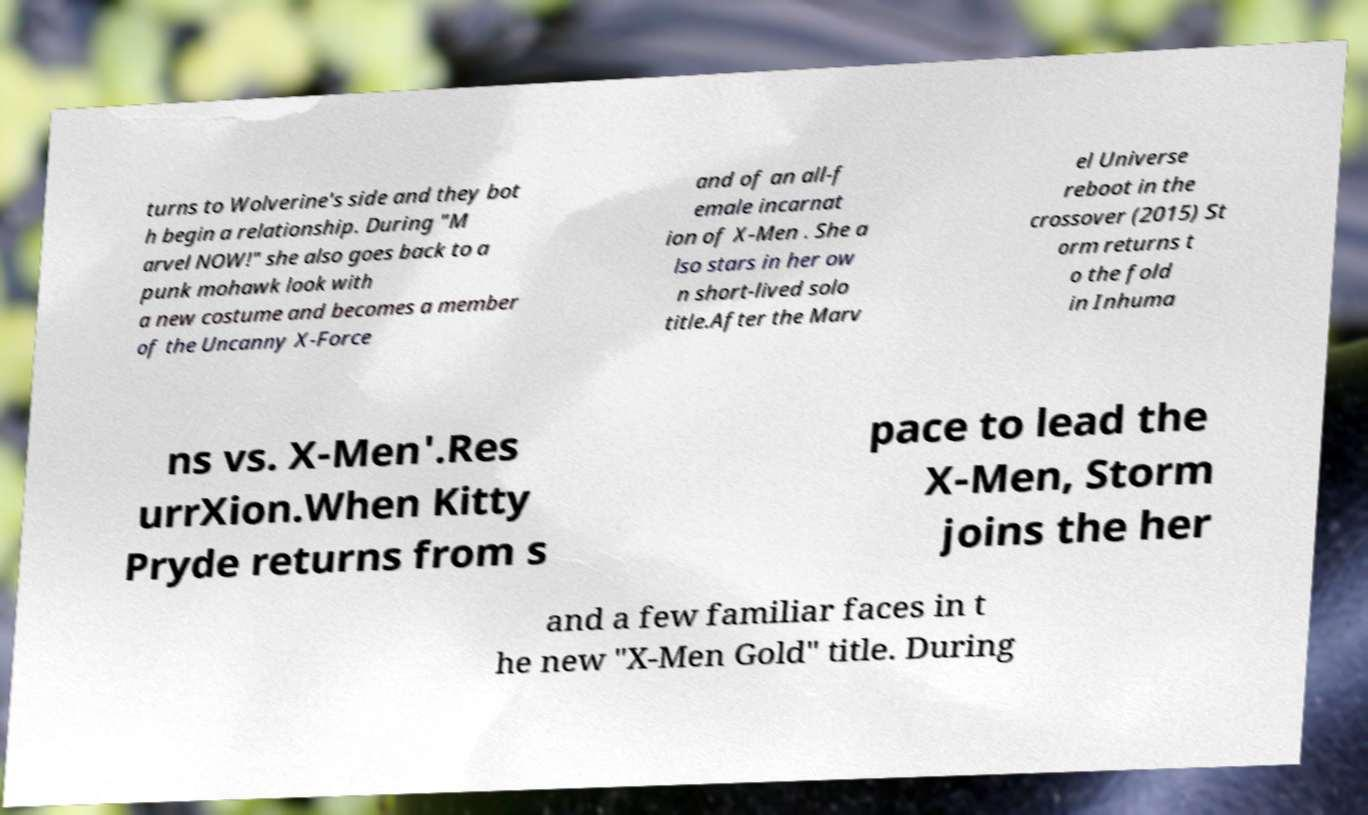Can you read and provide the text displayed in the image?This photo seems to have some interesting text. Can you extract and type it out for me? turns to Wolverine's side and they bot h begin a relationship. During "M arvel NOW!" she also goes back to a punk mohawk look with a new costume and becomes a member of the Uncanny X-Force and of an all-f emale incarnat ion of X-Men . She a lso stars in her ow n short-lived solo title.After the Marv el Universe reboot in the crossover (2015) St orm returns t o the fold in Inhuma ns vs. X-Men'.Res urrXion.When Kitty Pryde returns from s pace to lead the X-Men, Storm joins the her and a few familiar faces in t he new "X-Men Gold" title. During 